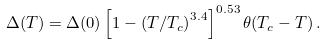<formula> <loc_0><loc_0><loc_500><loc_500>\Delta ( T ) = \Delta ( 0 ) \left [ { 1 - \left ( { T } / { T _ { c } } \right ) ^ { 3 . 4 } } \right ] ^ { 0 . 5 3 } \theta ( T _ { c } - T ) \, .</formula> 